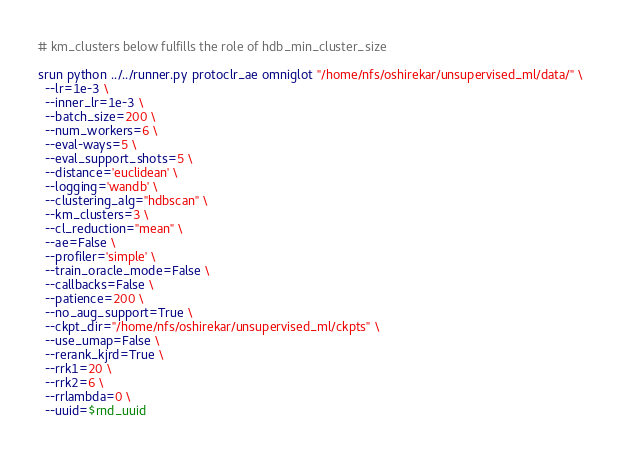<code> <loc_0><loc_0><loc_500><loc_500><_Bash_>
# km_clusters below fulfills the role of hdb_min_cluster_size

srun python ../../runner.py protoclr_ae omniglot "/home/nfs/oshirekar/unsupervised_ml/data/" \
  --lr=1e-3 \
  --inner_lr=1e-3 \
  --batch_size=200 \
  --num_workers=6 \
  --eval-ways=5 \
  --eval_support_shots=5 \
  --distance='euclidean' \
  --logging='wandb' \
  --clustering_alg="hdbscan" \
  --km_clusters=3 \
  --cl_reduction="mean" \
  --ae=False \
  --profiler='simple' \
  --train_oracle_mode=False \
  --callbacks=False \
  --patience=200 \
  --no_aug_support=True \
  --ckpt_dir="/home/nfs/oshirekar/unsupervised_ml/ckpts" \
  --use_umap=False \
  --rerank_kjrd=True \
  --rrk1=20 \
  --rrk2=6 \
  --rrlambda=0 \
  --uuid=$rnd_uuid
</code> 